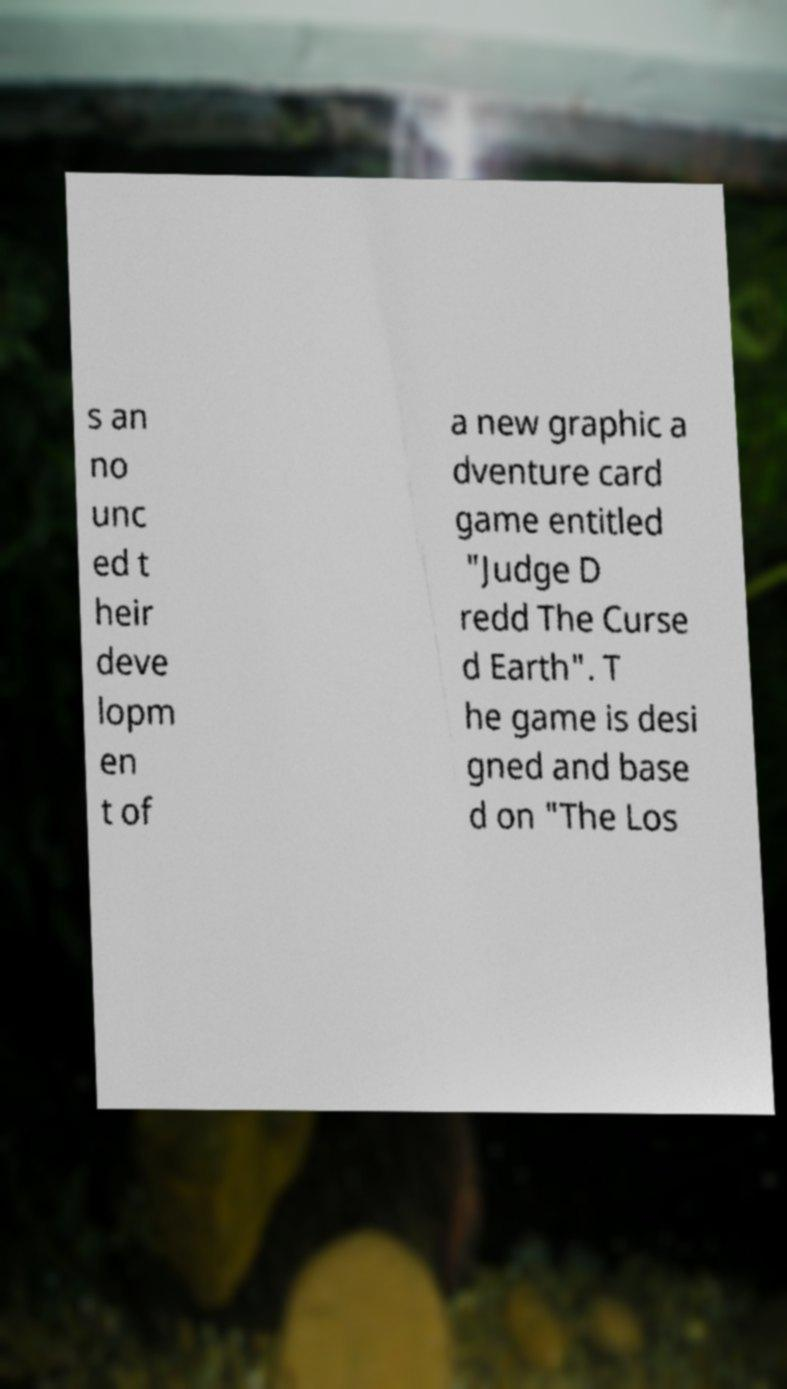Could you assist in decoding the text presented in this image and type it out clearly? s an no unc ed t heir deve lopm en t of a new graphic a dventure card game entitled "Judge D redd The Curse d Earth". T he game is desi gned and base d on "The Los 